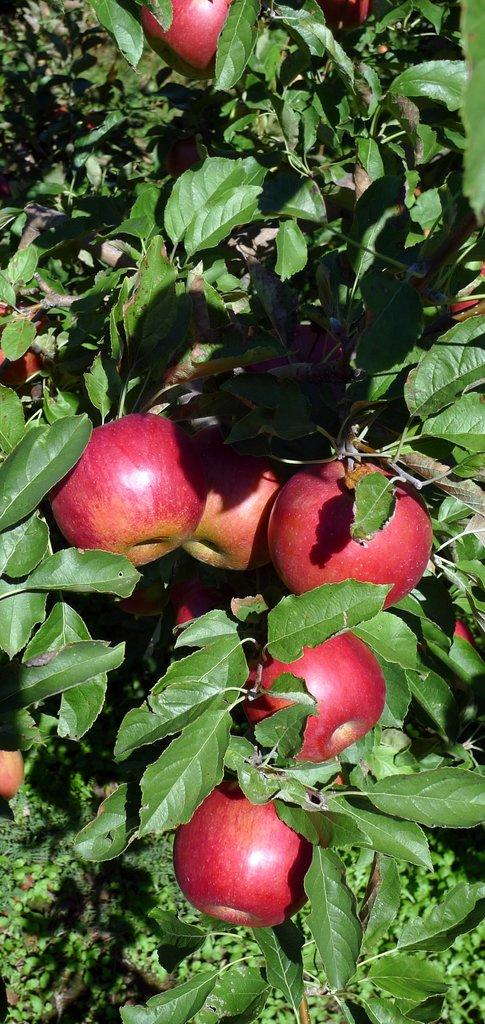What color are the leaves in the image? The leaves in the image are green. What type of fruit can be seen in the image? There are red color apples in the image. What type of fang can be seen in the image? There is no fang present in the image; it features green leaves and red apples. What songs are being sung by the apples in the image? The apples in the image are not singing songs; they are simply fruits. 